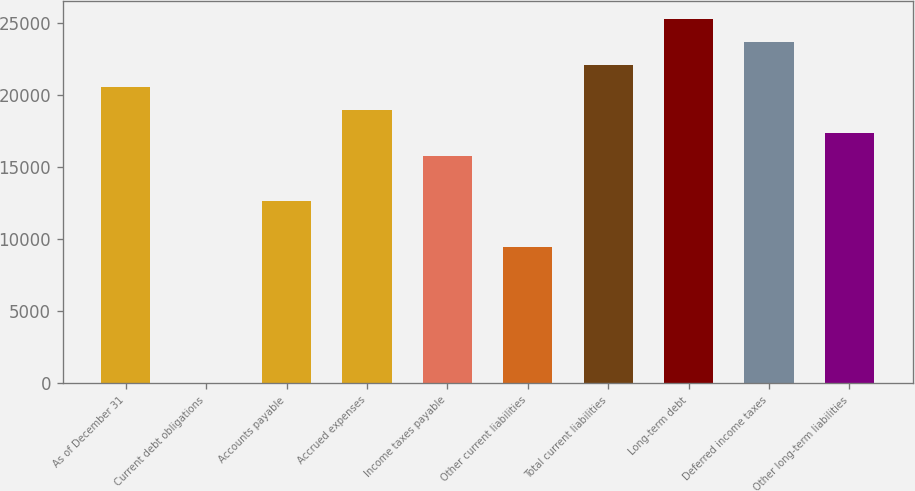Convert chart to OTSL. <chart><loc_0><loc_0><loc_500><loc_500><bar_chart><fcel>As of December 31<fcel>Current debt obligations<fcel>Accounts payable<fcel>Accrued expenses<fcel>Income taxes payable<fcel>Other current liabilities<fcel>Total current liabilities<fcel>Long-term debt<fcel>Deferred income taxes<fcel>Other long-term liabilities<nl><fcel>20527.5<fcel>7<fcel>12635<fcel>18949<fcel>15792<fcel>9478<fcel>22106<fcel>25263<fcel>23684.5<fcel>17370.5<nl></chart> 